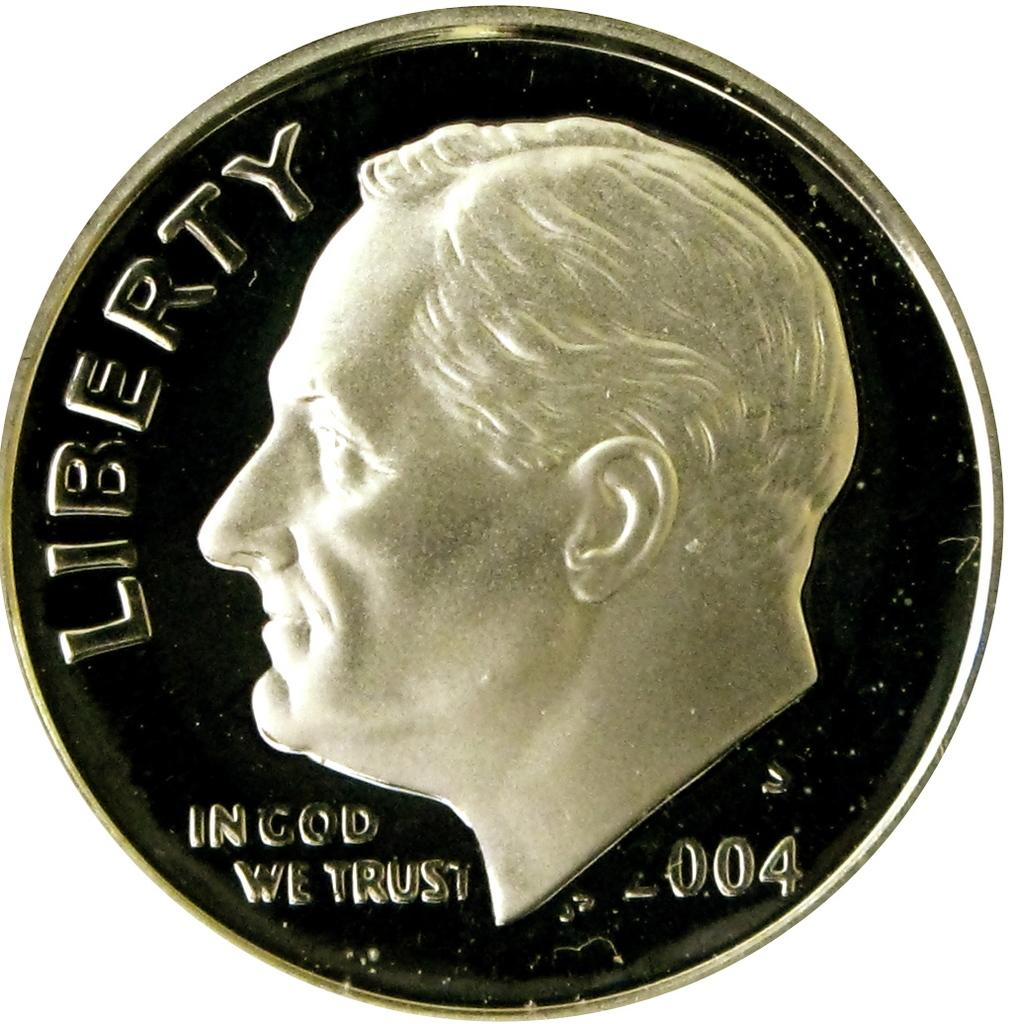<image>
Share a concise interpretation of the image provided. A Roosevelt dime with the word Liberty was minted in 2004. 